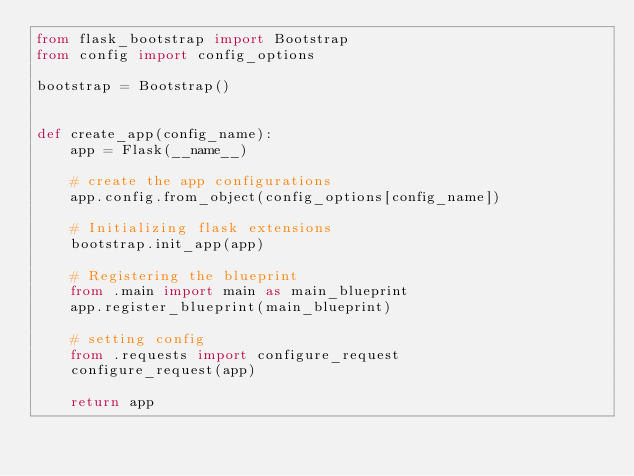Convert code to text. <code><loc_0><loc_0><loc_500><loc_500><_Python_>from flask_bootstrap import Bootstrap
from config import config_options

bootstrap = Bootstrap()


def create_app(config_name):
    app = Flask(__name__)

    # create the app configurations
    app.config.from_object(config_options[config_name])

    # Initializing flask extensions
    bootstrap.init_app(app)

    # Registering the blueprint
    from .main import main as main_blueprint
    app.register_blueprint(main_blueprint)

    # setting config
    from .requests import configure_request
    configure_request(app)

    return app
    </code> 